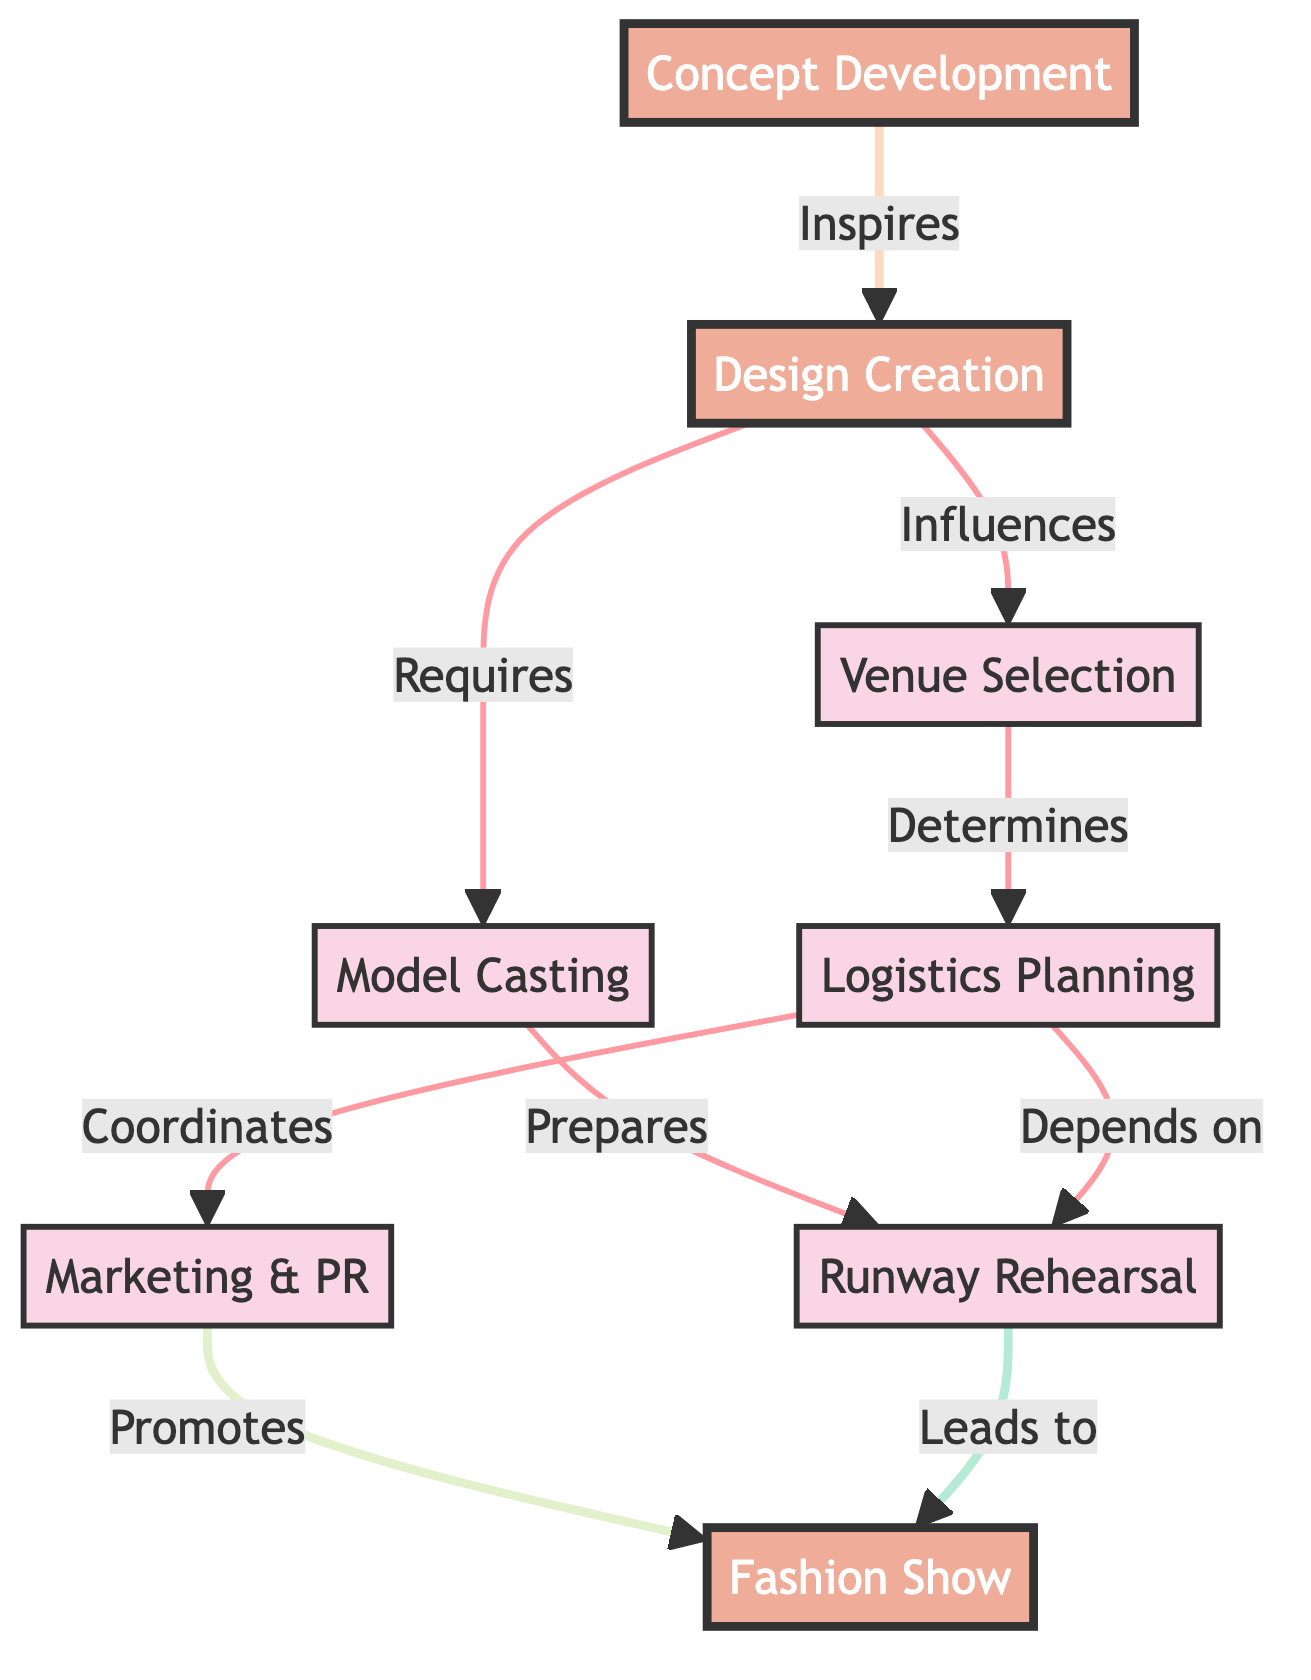What is the first step in the fashion show production process? The first node in the diagram represents the initial step, which is "Concept Development." This is clearly indicated as the starting point in the flowchart.
Answer: Concept Development How many main steps are involved in the fashion show production? By counting the distinct nodes in the diagram, there are eight main steps involved, which are Concept Development, Design Creation, Model Casting, Venue Selection, Logistics Planning, Marketing & PR, Runway Rehearsal, and Fashion Show.
Answer: 8 What does "Design Creation" influence? According to the diagram, the arrow from "Design Creation" points to "Venue Selection," indicating that the design work directly influences the choice of the venue for the show.
Answer: Venue Selection Which two nodes require model casting? The diagram indicates that "Design Creation" leads to "Model Casting," while "Runway Rehearsal" also connects back to "Model Casting," indicating that both elements require model casting to proceed.
Answer: Design Creation and Runway Rehearsal What does "Logistics Planning" depend on? In the flowchart, "Logistics Planning" is connected by an arrow to "Runway Rehearsal," indicating that it is dependent on the scheduling and coordination of the rehearsals.
Answer: Runway Rehearsal How does "Marketing & PR" interact with the final fashion show? The diagram shows that "Marketing & PR" promotes the "Fashion Show," indicating a direct relationship where the marketing strategies are focused on showcasing the final event.
Answer: Promotes In how many ways does "Concept Development" interact with other steps? "Concept Development" interacts with "Design Creation" as its direct successor, showing a singular direct influence. This is the only interaction noted in the diagram.
Answer: 1 What stage comes directly after "Runway Rehearsal"? According to the flowchart, "Runway Rehearsal" leads directly to the next step, which is "Fashion Show." This shows the progression from practice to actual event.
Answer: Fashion Show 